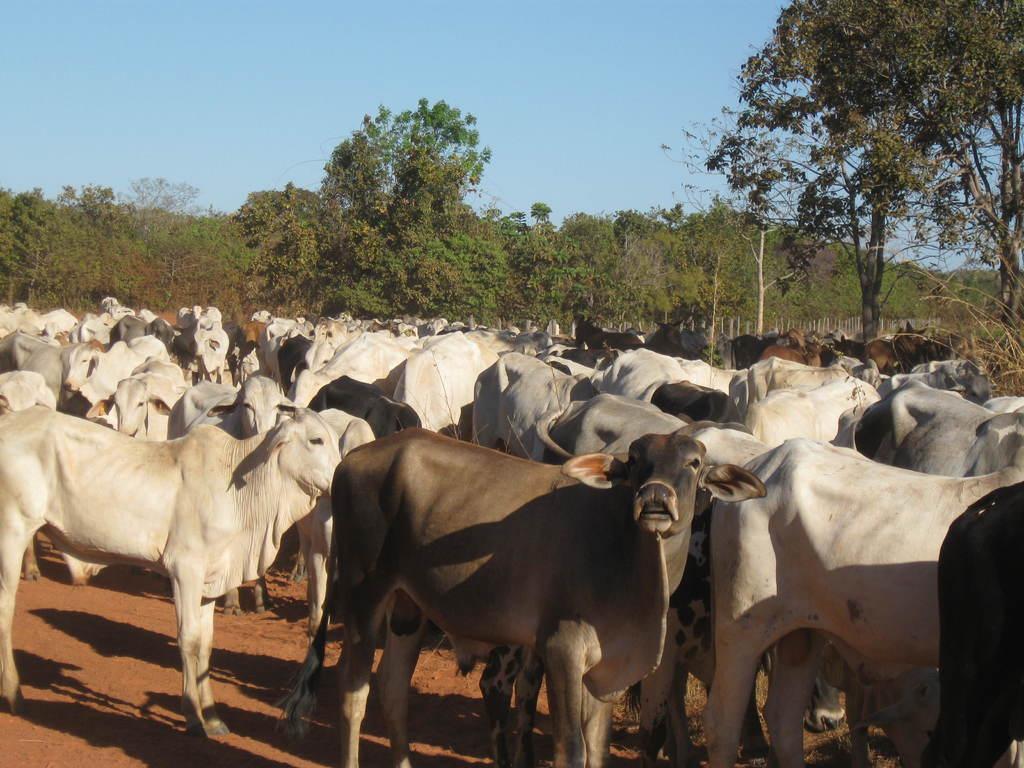Could you give a brief overview of what you see in this image? In this image I can see many cows on the ground. In the background there are many trees. At the top of the image I can see the sky. 